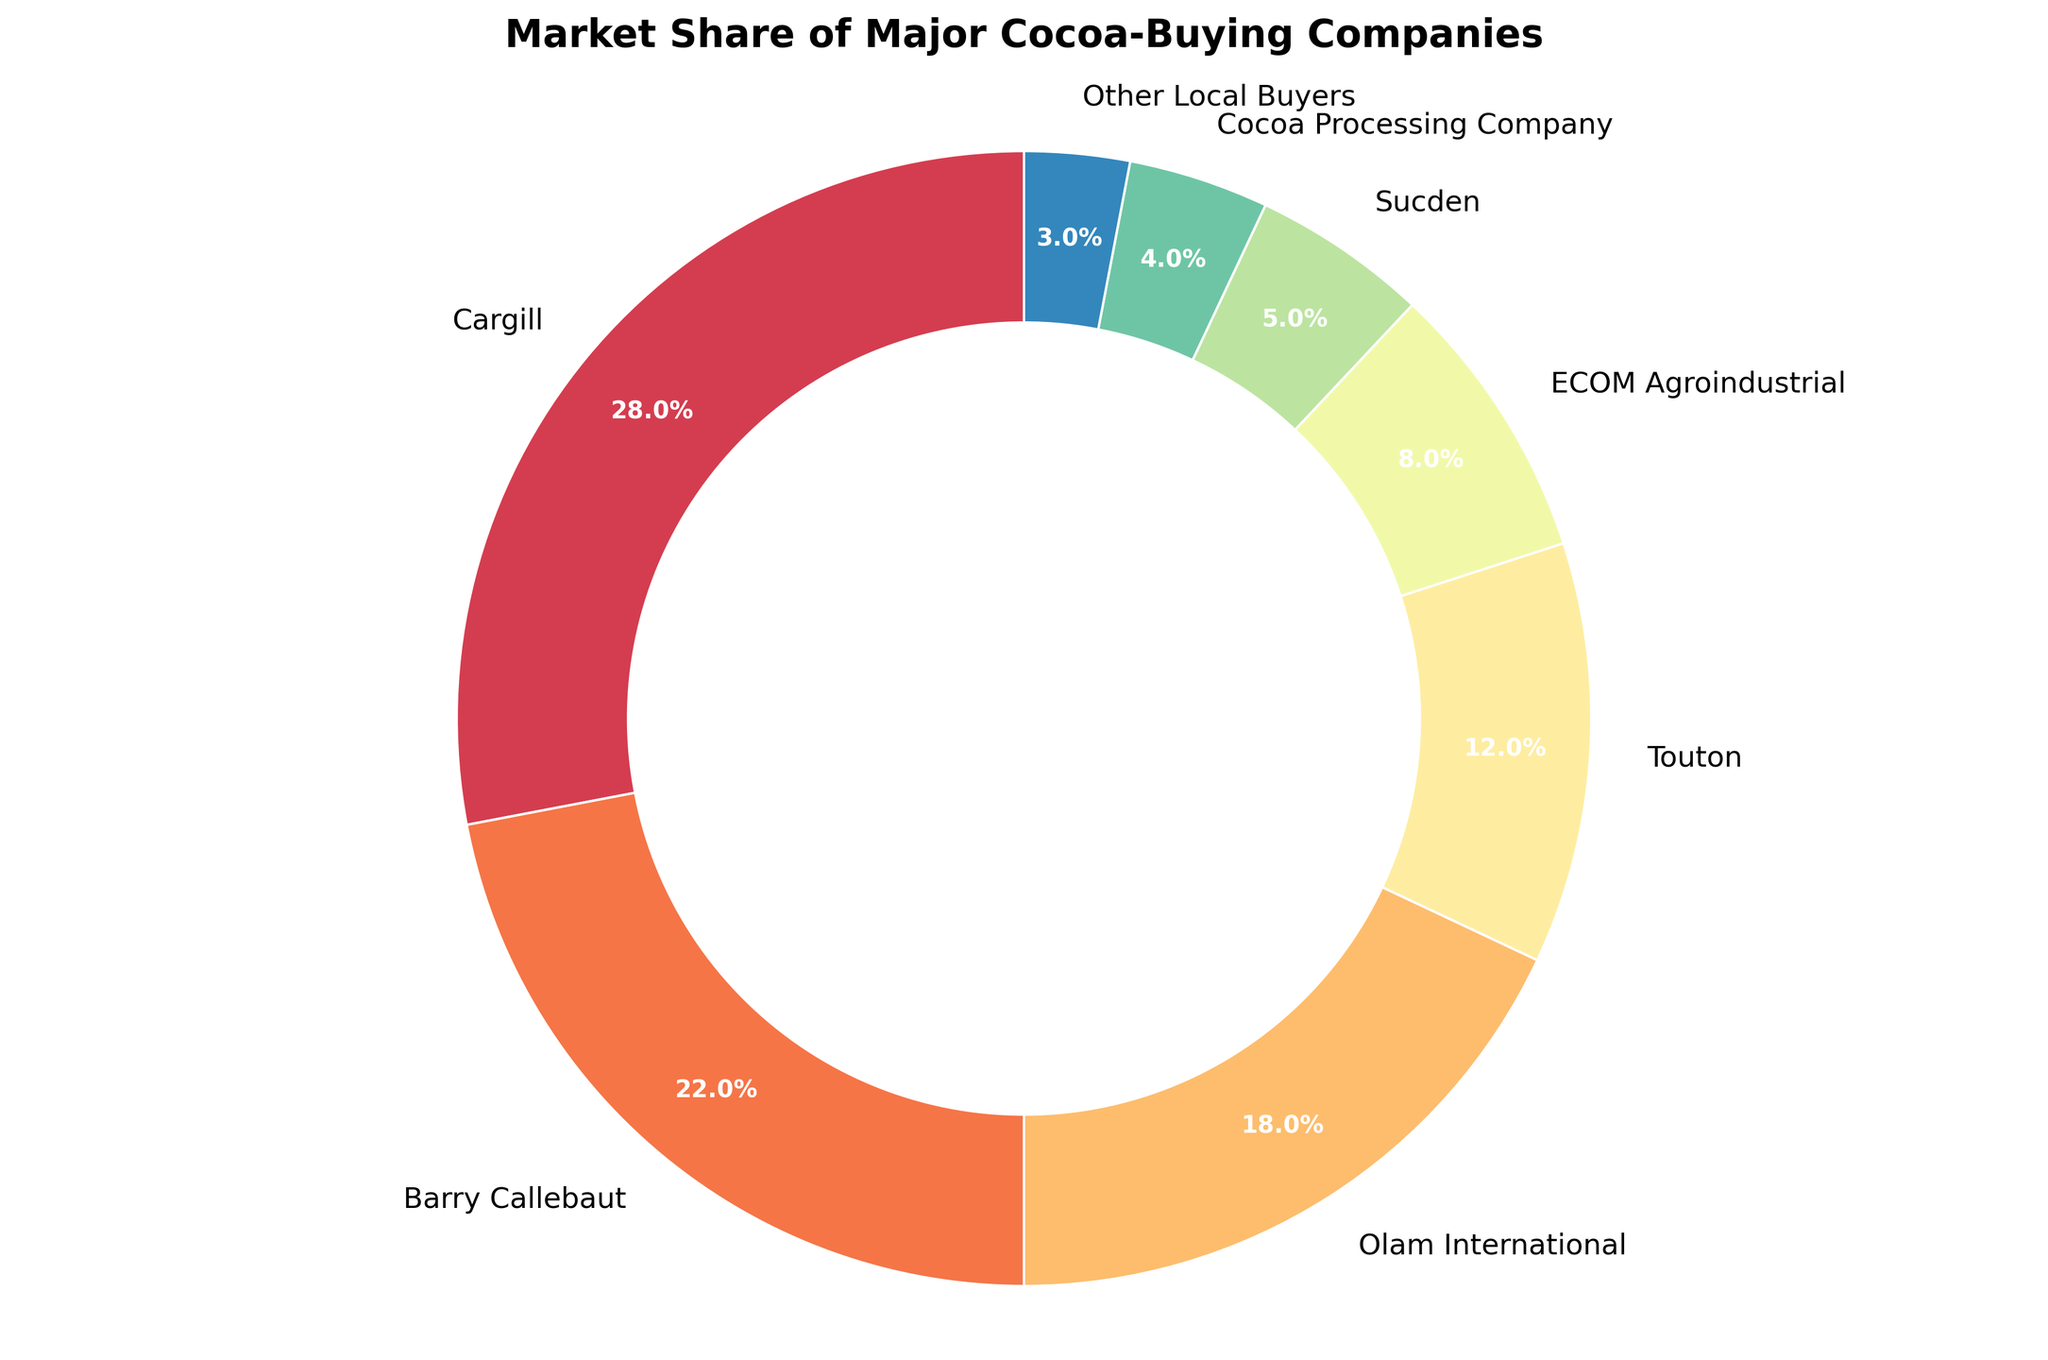What's the market share of Barry Callebaut? According to the pie chart, Barry Callebaut holds a 22% market share.
Answer: 22% Which company has the largest market share? The largest wedge in the pie chart belongs to Cargill, indicating it has the largest market share.
Answer: Cargill What is the combined market share of Olam International and Touton? Olam International has an 18% market share, and Touton has a 12% market share. Adding these two percentages gives 18% + 12%, which equals 30%.
Answer: 30% Which company has the smallest market share? The smallest wedge in the pie chart is attributed to Other Local Buyers, which indicates they have the smallest market share at 3%.
Answer: Other Local Buyers How does the market share of ECOM Agroindustrial compare to Sucden? The market share of ECOM Agroindustrial is 8%, while Sucden's is 5%. Since 8% is greater than 5%, ECOM Agroindustrial has a larger market share than Sucden.
Answer: ECOM Agroindustrial has a larger market share than Sucden What fraction of the market is shared by Cargill, Barry Callebaut, and Olam International combined? Cargill has a 28% market share, Barry Callebaut has 22%, and Olam International has 18%. Adding these gives 28% + 22% + 18% = 68%. In fractions, 68% is equivalent to 68/100 or 68%.
Answer: 68% Which companies have market shares greater than 10%? Cargill, Barry Callebaut, Olam International, and Touton each have market shares greater than 10%, as indicated by the size of their respective wedges in the pie chart.
Answer: Cargill, Barry Callebaut, Olam International, Touton Which company’s market share is closest in size to the aggregate market share of Sucden, Cocoa Processing Company, and Other Local Buyers? Sucden has a 5% market share, Cocoa Processing Company has 4%, and Other Local Buyers have 3%. Adding these gives 5% + 4% + 3% = 12%. Touton also has a 12% market share.
Answer: Touton If the total market size is represented by 100 units, how many units correspond to the market share of Cargill? Cargill has a 28% market share. If the total market size is 100 units, Cargill's share in units would be 28% of 100, which calculates to 28 units.
Answer: 28 units 